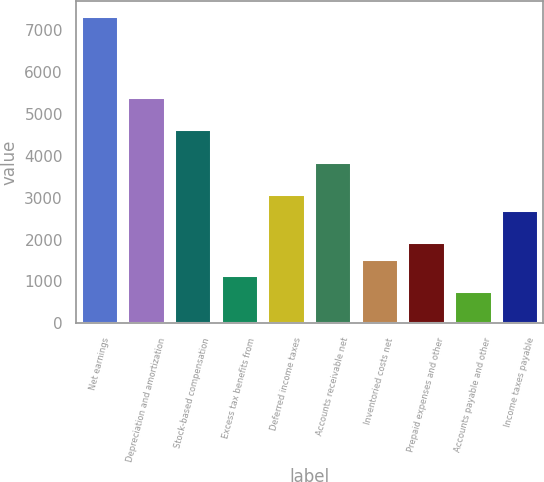Convert chart. <chart><loc_0><loc_0><loc_500><loc_500><bar_chart><fcel>Net earnings<fcel>Depreciation and amortization<fcel>Stock-based compensation<fcel>Excess tax benefits from<fcel>Deferred income taxes<fcel>Accounts receivable net<fcel>Inventoried costs net<fcel>Prepaid expenses and other<fcel>Accounts payable and other<fcel>Income taxes payable<nl><fcel>7335.1<fcel>5405.6<fcel>4633.8<fcel>1160.7<fcel>3090.2<fcel>3862<fcel>1546.6<fcel>1932.5<fcel>774.8<fcel>2704.3<nl></chart> 